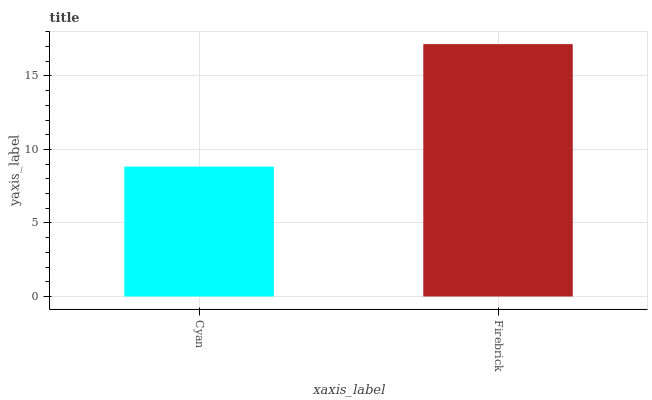Is Cyan the minimum?
Answer yes or no. Yes. Is Firebrick the maximum?
Answer yes or no. Yes. Is Firebrick the minimum?
Answer yes or no. No. Is Firebrick greater than Cyan?
Answer yes or no. Yes. Is Cyan less than Firebrick?
Answer yes or no. Yes. Is Cyan greater than Firebrick?
Answer yes or no. No. Is Firebrick less than Cyan?
Answer yes or no. No. Is Firebrick the high median?
Answer yes or no. Yes. Is Cyan the low median?
Answer yes or no. Yes. Is Cyan the high median?
Answer yes or no. No. Is Firebrick the low median?
Answer yes or no. No. 